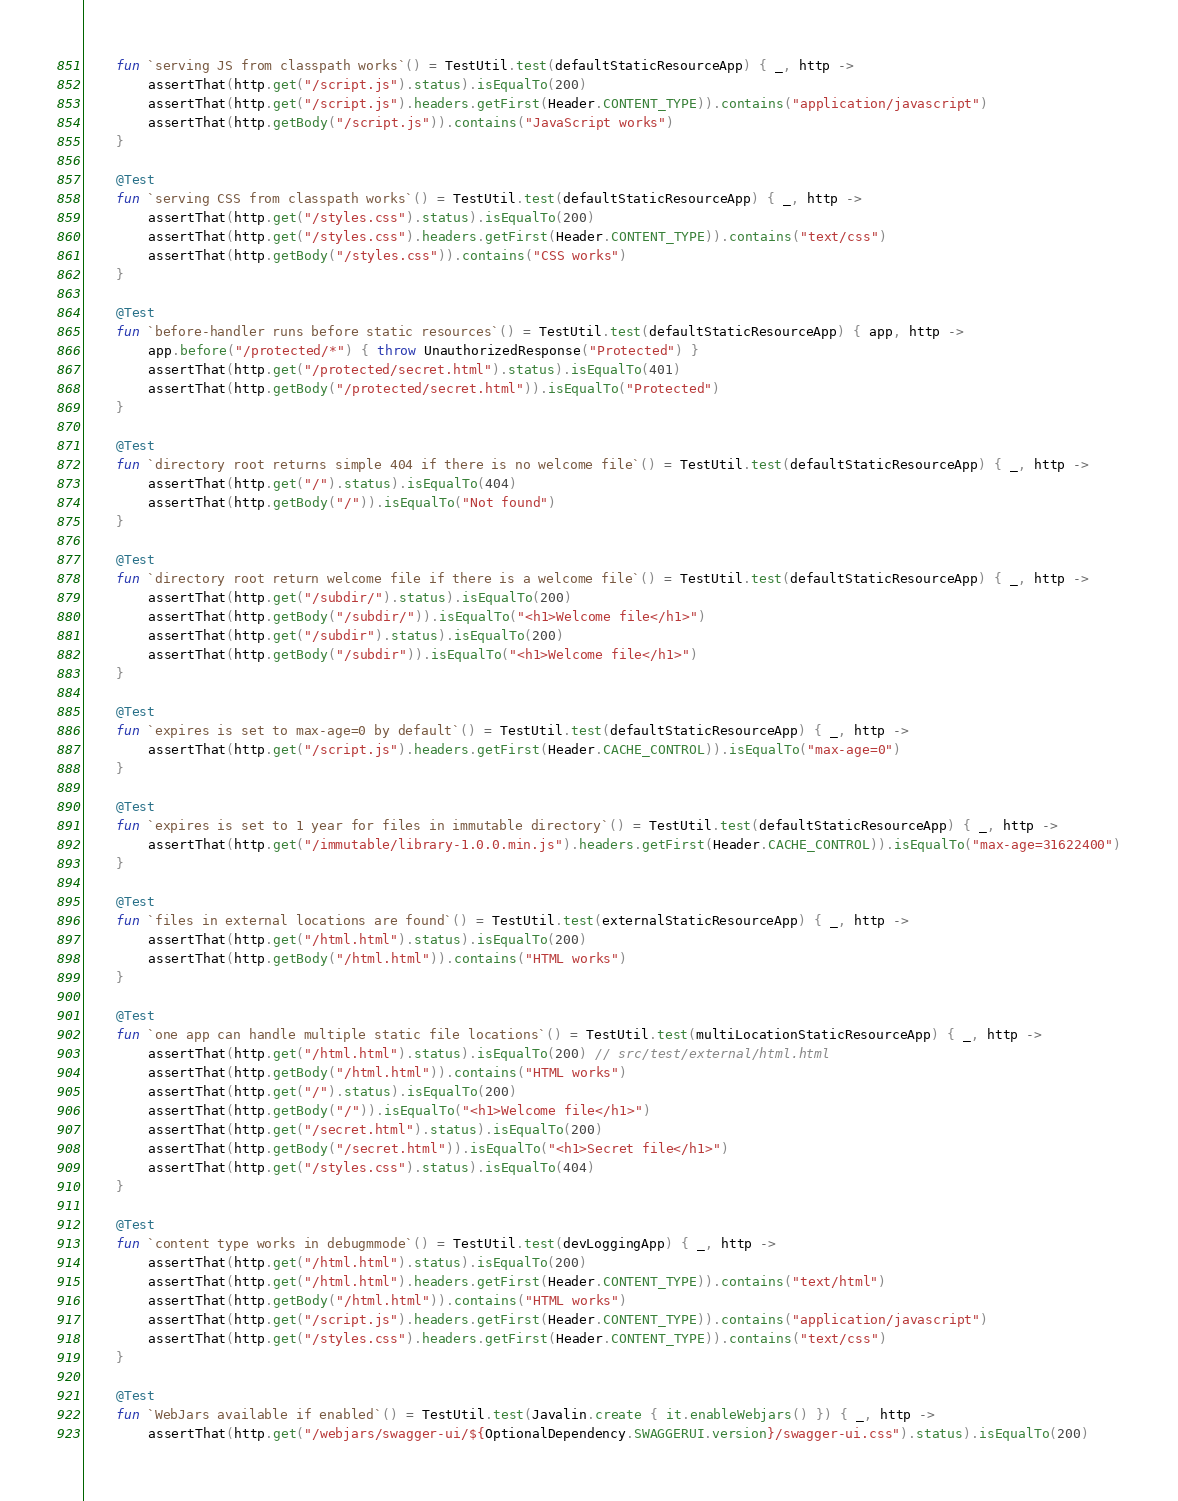Convert code to text. <code><loc_0><loc_0><loc_500><loc_500><_Kotlin_>    fun `serving JS from classpath works`() = TestUtil.test(defaultStaticResourceApp) { _, http ->
        assertThat(http.get("/script.js").status).isEqualTo(200)
        assertThat(http.get("/script.js").headers.getFirst(Header.CONTENT_TYPE)).contains("application/javascript")
        assertThat(http.getBody("/script.js")).contains("JavaScript works")
    }

    @Test
    fun `serving CSS from classpath works`() = TestUtil.test(defaultStaticResourceApp) { _, http ->
        assertThat(http.get("/styles.css").status).isEqualTo(200)
        assertThat(http.get("/styles.css").headers.getFirst(Header.CONTENT_TYPE)).contains("text/css")
        assertThat(http.getBody("/styles.css")).contains("CSS works")
    }

    @Test
    fun `before-handler runs before static resources`() = TestUtil.test(defaultStaticResourceApp) { app, http ->
        app.before("/protected/*") { throw UnauthorizedResponse("Protected") }
        assertThat(http.get("/protected/secret.html").status).isEqualTo(401)
        assertThat(http.getBody("/protected/secret.html")).isEqualTo("Protected")
    }

    @Test
    fun `directory root returns simple 404 if there is no welcome file`() = TestUtil.test(defaultStaticResourceApp) { _, http ->
        assertThat(http.get("/").status).isEqualTo(404)
        assertThat(http.getBody("/")).isEqualTo("Not found")
    }

    @Test
    fun `directory root return welcome file if there is a welcome file`() = TestUtil.test(defaultStaticResourceApp) { _, http ->
        assertThat(http.get("/subdir/").status).isEqualTo(200)
        assertThat(http.getBody("/subdir/")).isEqualTo("<h1>Welcome file</h1>")
        assertThat(http.get("/subdir").status).isEqualTo(200)
        assertThat(http.getBody("/subdir")).isEqualTo("<h1>Welcome file</h1>")
    }

    @Test
    fun `expires is set to max-age=0 by default`() = TestUtil.test(defaultStaticResourceApp) { _, http ->
        assertThat(http.get("/script.js").headers.getFirst(Header.CACHE_CONTROL)).isEqualTo("max-age=0")
    }

    @Test
    fun `expires is set to 1 year for files in immutable directory`() = TestUtil.test(defaultStaticResourceApp) { _, http ->
        assertThat(http.get("/immutable/library-1.0.0.min.js").headers.getFirst(Header.CACHE_CONTROL)).isEqualTo("max-age=31622400")
    }

    @Test
    fun `files in external locations are found`() = TestUtil.test(externalStaticResourceApp) { _, http ->
        assertThat(http.get("/html.html").status).isEqualTo(200)
        assertThat(http.getBody("/html.html")).contains("HTML works")
    }

    @Test
    fun `one app can handle multiple static file locations`() = TestUtil.test(multiLocationStaticResourceApp) { _, http ->
        assertThat(http.get("/html.html").status).isEqualTo(200) // src/test/external/html.html
        assertThat(http.getBody("/html.html")).contains("HTML works")
        assertThat(http.get("/").status).isEqualTo(200)
        assertThat(http.getBody("/")).isEqualTo("<h1>Welcome file</h1>")
        assertThat(http.get("/secret.html").status).isEqualTo(200)
        assertThat(http.getBody("/secret.html")).isEqualTo("<h1>Secret file</h1>")
        assertThat(http.get("/styles.css").status).isEqualTo(404)
    }

    @Test
    fun `content type works in debugmmode`() = TestUtil.test(devLoggingApp) { _, http ->
        assertThat(http.get("/html.html").status).isEqualTo(200)
        assertThat(http.get("/html.html").headers.getFirst(Header.CONTENT_TYPE)).contains("text/html")
        assertThat(http.getBody("/html.html")).contains("HTML works")
        assertThat(http.get("/script.js").headers.getFirst(Header.CONTENT_TYPE)).contains("application/javascript")
        assertThat(http.get("/styles.css").headers.getFirst(Header.CONTENT_TYPE)).contains("text/css")
    }

    @Test
    fun `WebJars available if enabled`() = TestUtil.test(Javalin.create { it.enableWebjars() }) { _, http ->
        assertThat(http.get("/webjars/swagger-ui/${OptionalDependency.SWAGGERUI.version}/swagger-ui.css").status).isEqualTo(200)</code> 